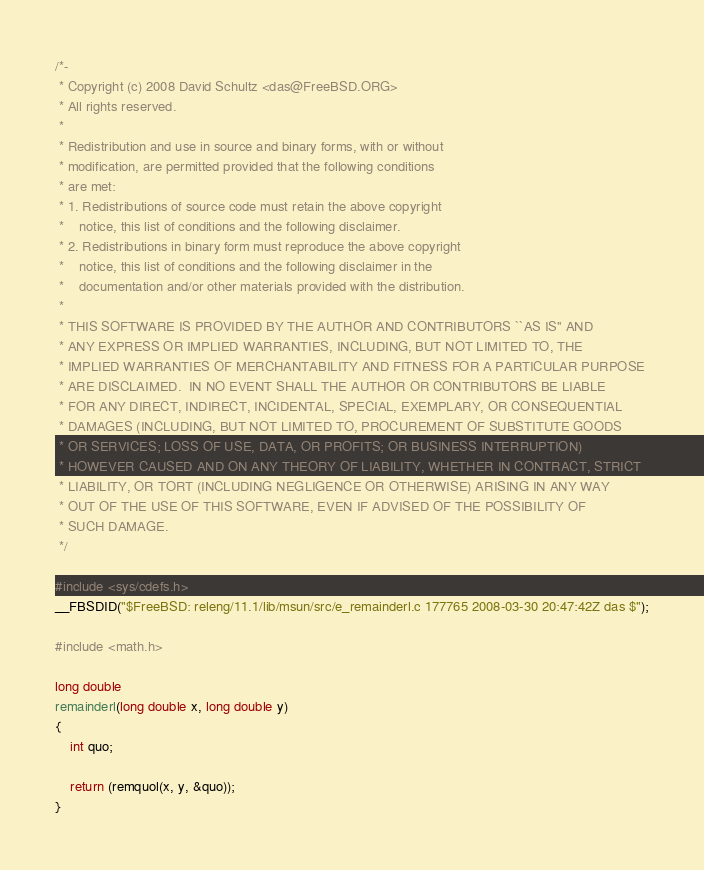<code> <loc_0><loc_0><loc_500><loc_500><_C_>/*-
 * Copyright (c) 2008 David Schultz <das@FreeBSD.ORG>
 * All rights reserved.
 *
 * Redistribution and use in source and binary forms, with or without
 * modification, are permitted provided that the following conditions
 * are met:
 * 1. Redistributions of source code must retain the above copyright
 *    notice, this list of conditions and the following disclaimer.
 * 2. Redistributions in binary form must reproduce the above copyright
 *    notice, this list of conditions and the following disclaimer in the
 *    documentation and/or other materials provided with the distribution.
 *
 * THIS SOFTWARE IS PROVIDED BY THE AUTHOR AND CONTRIBUTORS ``AS IS'' AND
 * ANY EXPRESS OR IMPLIED WARRANTIES, INCLUDING, BUT NOT LIMITED TO, THE
 * IMPLIED WARRANTIES OF MERCHANTABILITY AND FITNESS FOR A PARTICULAR PURPOSE
 * ARE DISCLAIMED.  IN NO EVENT SHALL THE AUTHOR OR CONTRIBUTORS BE LIABLE
 * FOR ANY DIRECT, INDIRECT, INCIDENTAL, SPECIAL, EXEMPLARY, OR CONSEQUENTIAL
 * DAMAGES (INCLUDING, BUT NOT LIMITED TO, PROCUREMENT OF SUBSTITUTE GOODS
 * OR SERVICES; LOSS OF USE, DATA, OR PROFITS; OR BUSINESS INTERRUPTION)
 * HOWEVER CAUSED AND ON ANY THEORY OF LIABILITY, WHETHER IN CONTRACT, STRICT
 * LIABILITY, OR TORT (INCLUDING NEGLIGENCE OR OTHERWISE) ARISING IN ANY WAY
 * OUT OF THE USE OF THIS SOFTWARE, EVEN IF ADVISED OF THE POSSIBILITY OF
 * SUCH DAMAGE.
 */

#include <sys/cdefs.h>
__FBSDID("$FreeBSD: releng/11.1/lib/msun/src/e_remainderl.c 177765 2008-03-30 20:47:42Z das $");

#include <math.h>

long double
remainderl(long double x, long double y)
{
	int quo;

	return (remquol(x, y, &quo));
}
</code> 